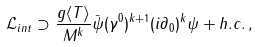<formula> <loc_0><loc_0><loc_500><loc_500>\mathcal { L } _ { i n t } \supset \frac { g \langle T \rangle } { M ^ { k } } \bar { \psi } ( \gamma ^ { 0 } ) ^ { k + 1 } ( i \partial _ { 0 } ) ^ { k } \psi + h . c . \, ,</formula> 